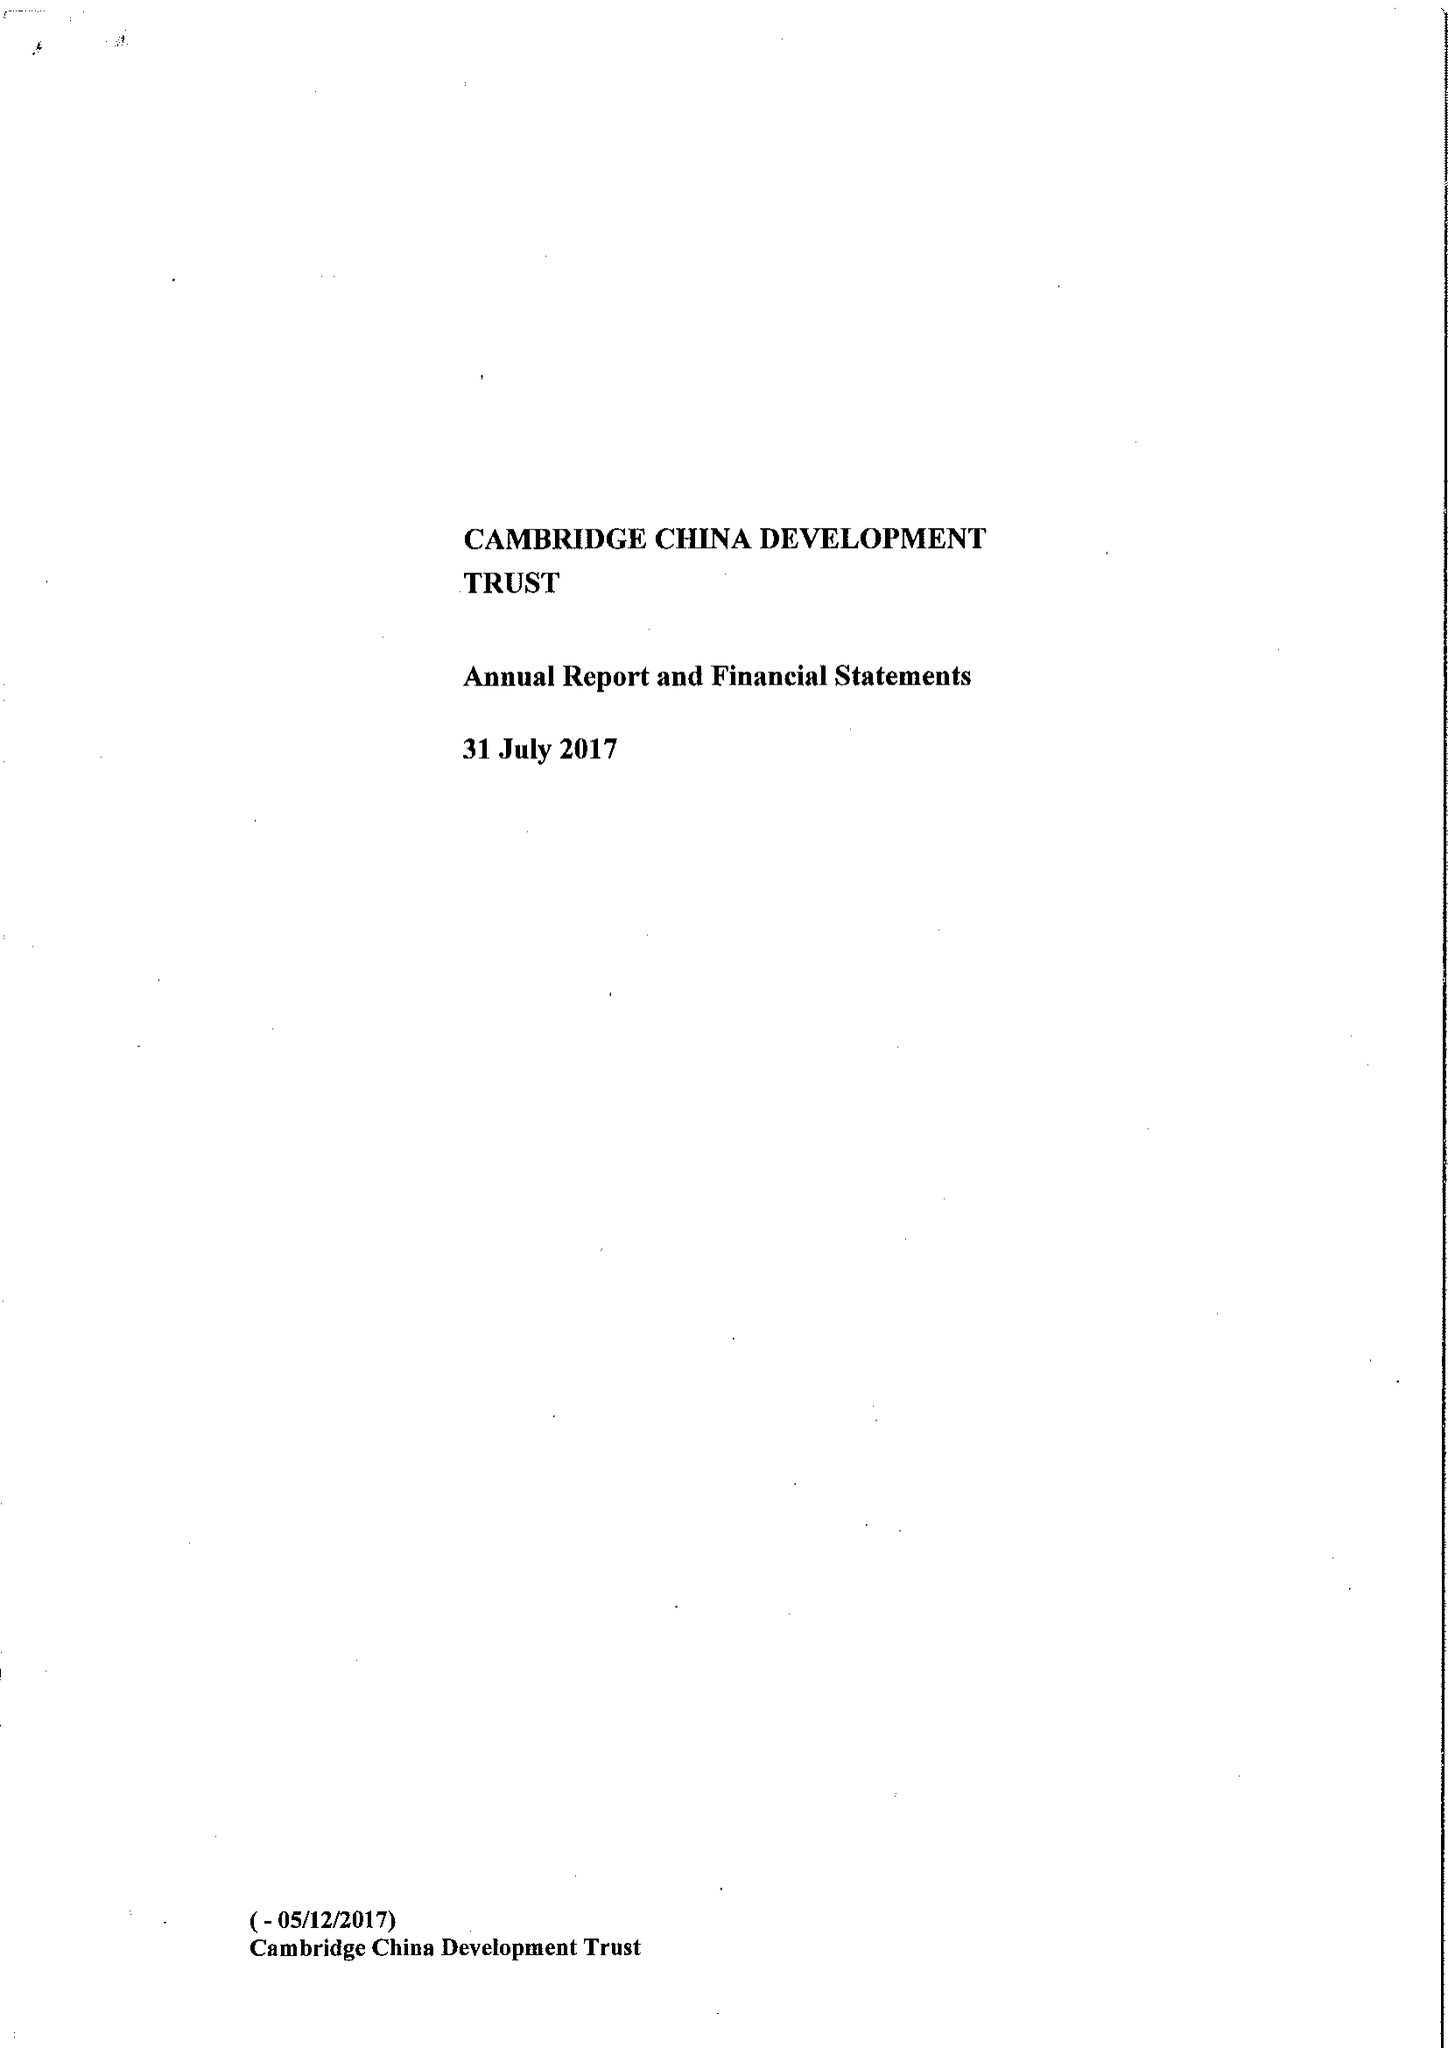What is the value for the address__postcode?
Answer the question using a single word or phrase. CB2 1TQ 